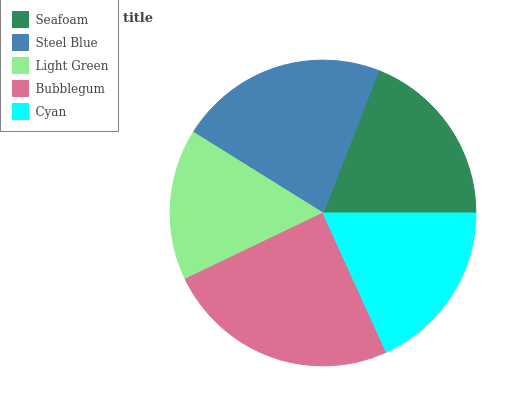Is Light Green the minimum?
Answer yes or no. Yes. Is Bubblegum the maximum?
Answer yes or no. Yes. Is Steel Blue the minimum?
Answer yes or no. No. Is Steel Blue the maximum?
Answer yes or no. No. Is Steel Blue greater than Seafoam?
Answer yes or no. Yes. Is Seafoam less than Steel Blue?
Answer yes or no. Yes. Is Seafoam greater than Steel Blue?
Answer yes or no. No. Is Steel Blue less than Seafoam?
Answer yes or no. No. Is Seafoam the high median?
Answer yes or no. Yes. Is Seafoam the low median?
Answer yes or no. Yes. Is Bubblegum the high median?
Answer yes or no. No. Is Cyan the low median?
Answer yes or no. No. 